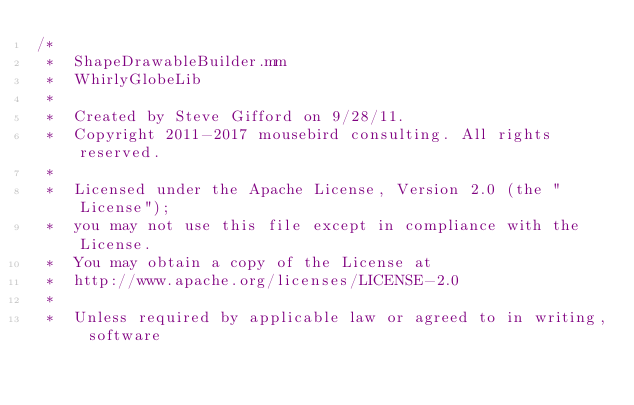Convert code to text. <code><loc_0><loc_0><loc_500><loc_500><_ObjectiveC_>/*
 *  ShapeDrawableBuilder.mm
 *  WhirlyGlobeLib
 *
 *  Created by Steve Gifford on 9/28/11.
 *  Copyright 2011-2017 mousebird consulting. All rights reserved.
 *
 *  Licensed under the Apache License, Version 2.0 (the "License");
 *  you may not use this file except in compliance with the License.
 *  You may obtain a copy of the License at
 *  http://www.apache.org/licenses/LICENSE-2.0
 *
 *  Unless required by applicable law or agreed to in writing, software</code> 